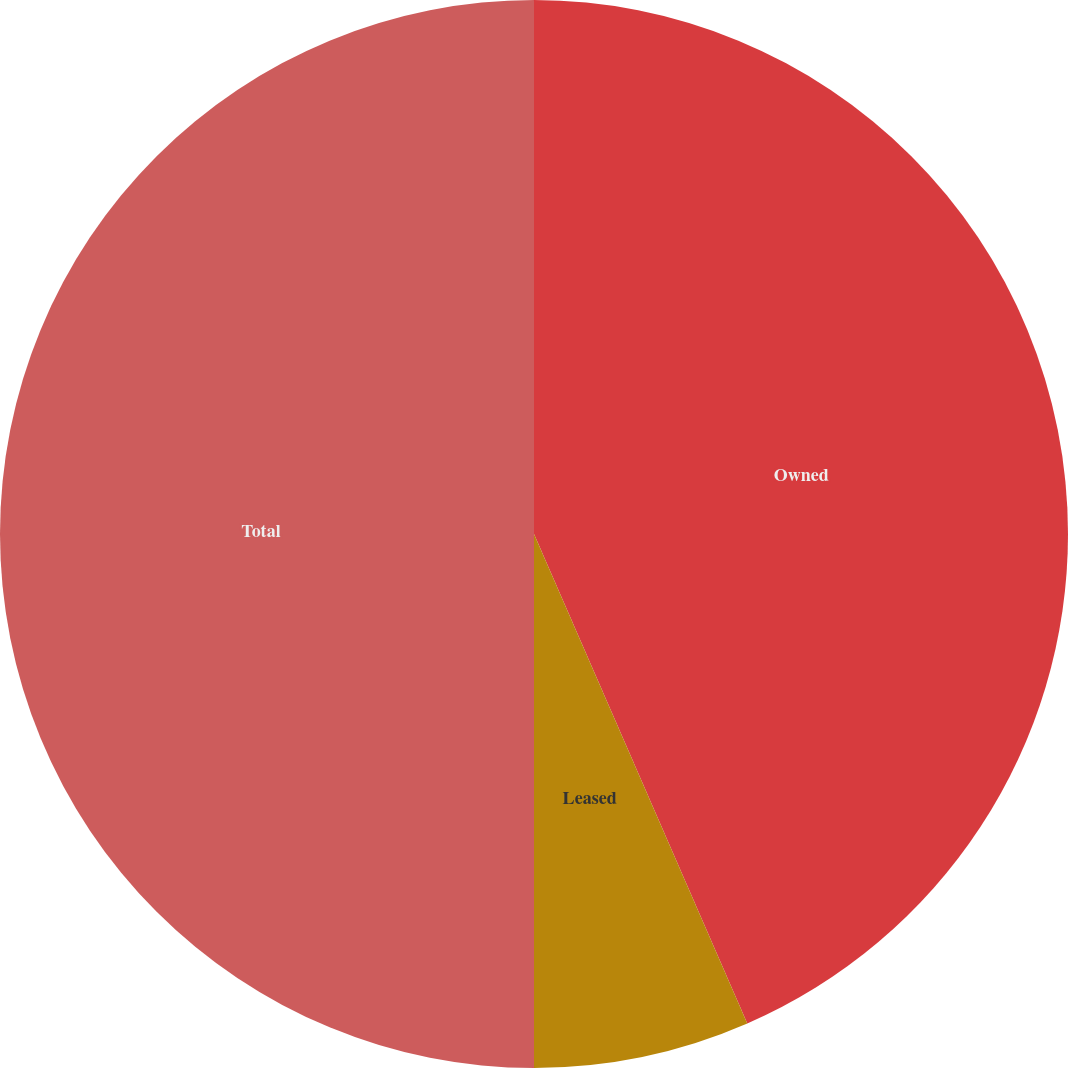Convert chart to OTSL. <chart><loc_0><loc_0><loc_500><loc_500><pie_chart><fcel>Owned<fcel>Leased<fcel>Total<nl><fcel>43.46%<fcel>6.54%<fcel>50.0%<nl></chart> 